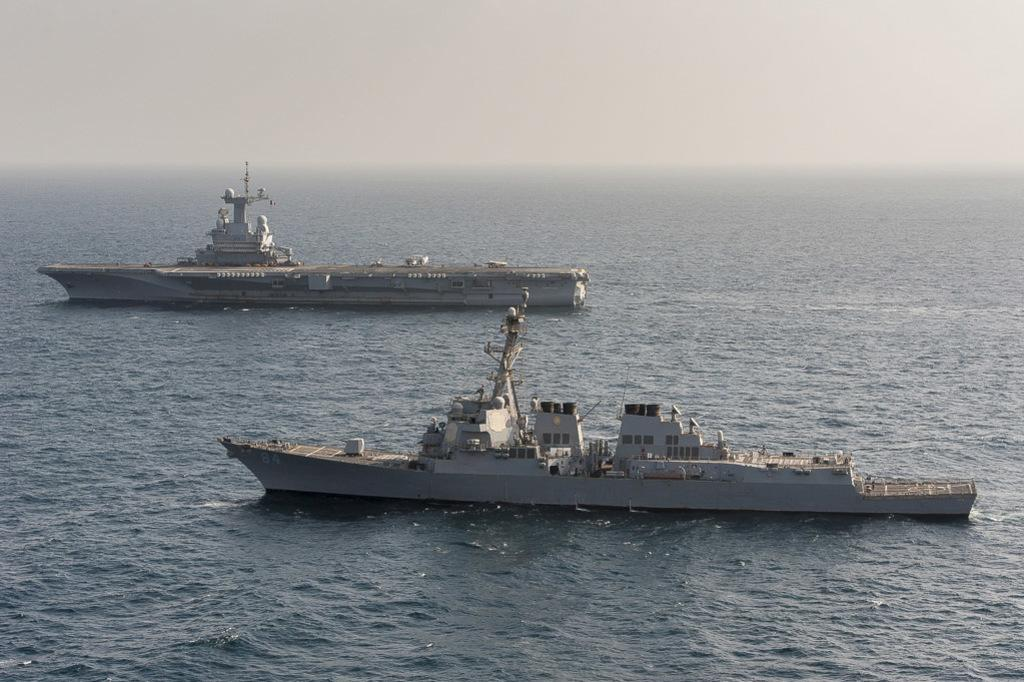What can be seen in the image? There are two ships in the image. Where are the ships located? The ships are in the water. How would you describe the weather in the image? The sky is foggy in the image. What type of rod can be seen on the ships in the image? There is no rod visible on the ships in the image. 